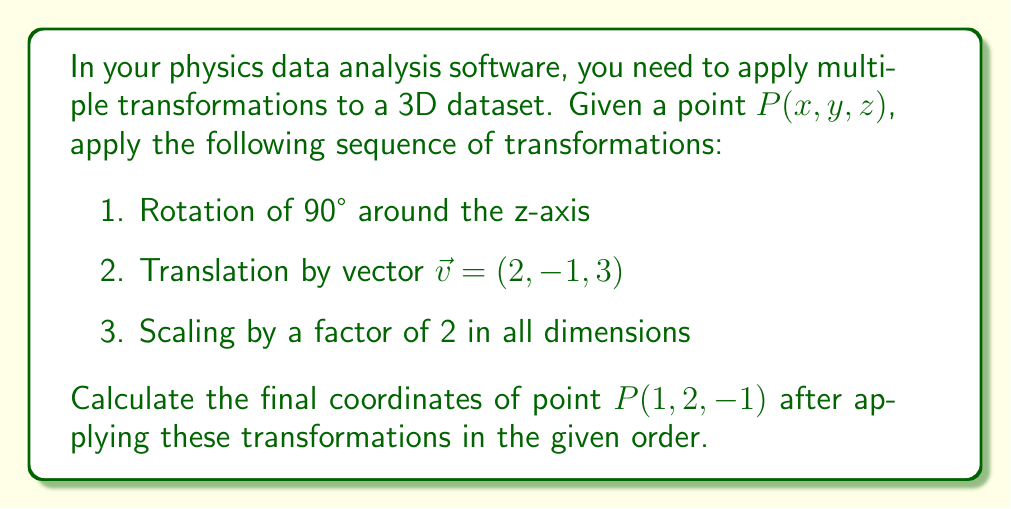Can you answer this question? Let's approach this step-by-step:

1. Rotation of 90° around the z-axis:
   The rotation matrix for 90° (or $\frac{\pi}{2}$ radians) around the z-axis is:
   $$R_z = \begin{pmatrix}
   0 & -1 & 0 \\
   1 & 0 & 0 \\
   0 & 0 & 1
   \end{pmatrix}$$

   Applying this to $P(1, 2, -1)$:
   $$\begin{pmatrix}
   0 & -1 & 0 \\
   1 & 0 & 0 \\
   0 & 0 & 1
   \end{pmatrix} \begin{pmatrix} 1 \\ 2 \\ -1 \end{pmatrix} = \begin{pmatrix} -2 \\ 1 \\ -1 \end{pmatrix}$$

2. Translation by vector $\vec{v} = (2, -1, 3)$:
   Add the translation vector to the result from step 1:
   $$\begin{pmatrix} -2 \\ 1 \\ -1 \end{pmatrix} + \begin{pmatrix} 2 \\ -1 \\ 3 \end{pmatrix} = \begin{pmatrix} 0 \\ 0 \\ 2 \end{pmatrix}$$

3. Scaling by a factor of 2 in all dimensions:
   Multiply each coordinate by 2:
   $$2 \cdot \begin{pmatrix} 0 \\ 0 \\ 2 \end{pmatrix} = \begin{pmatrix} 0 \\ 0 \\ 4 \end{pmatrix}$$

Therefore, the final coordinates of point $P$ after applying all transformations are $(0, 0, 4)$.
Answer: $(0, 0, 4)$ 